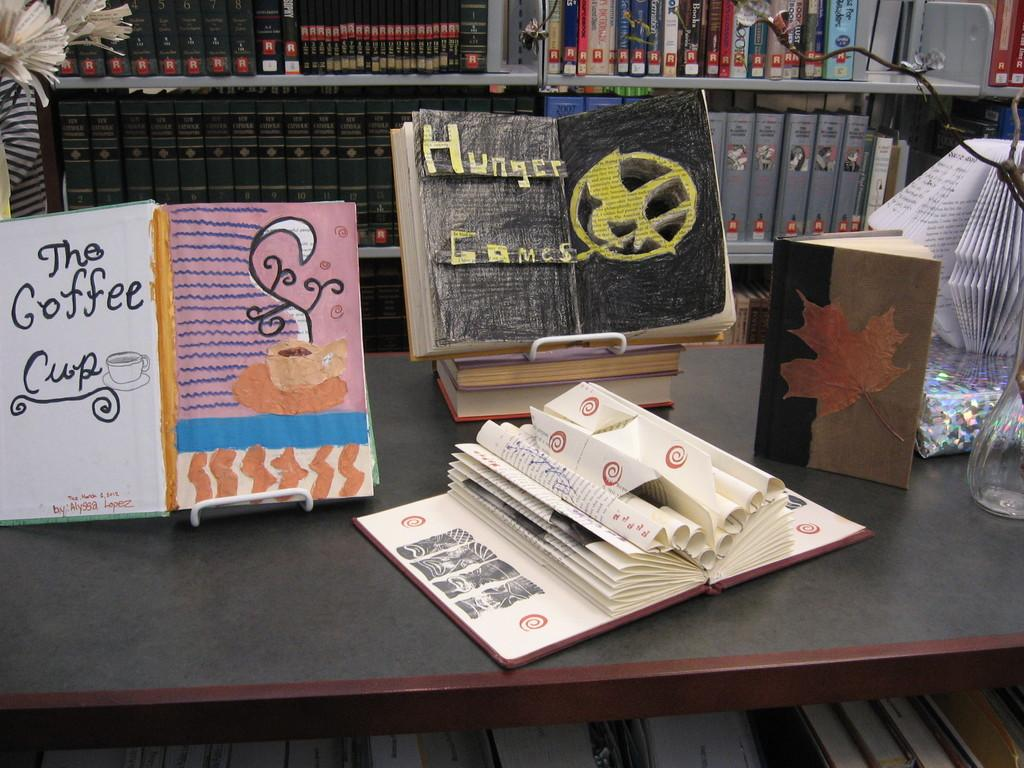<image>
Write a terse but informative summary of the picture. The middle display on a table of books that are open to a page that has been modified and made into a 3-d image is Hunger Games. 